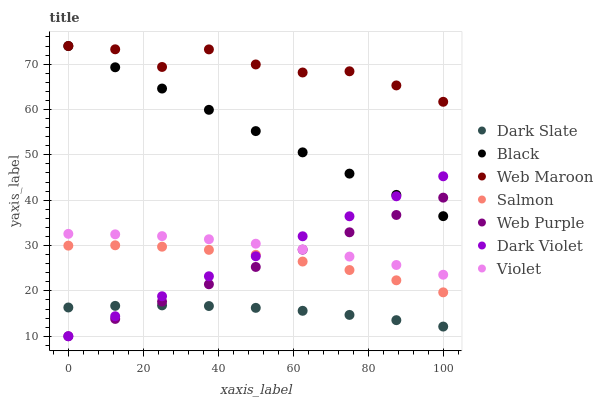Does Dark Slate have the minimum area under the curve?
Answer yes or no. Yes. Does Web Maroon have the maximum area under the curve?
Answer yes or no. Yes. Does Dark Violet have the minimum area under the curve?
Answer yes or no. No. Does Dark Violet have the maximum area under the curve?
Answer yes or no. No. Is Black the smoothest?
Answer yes or no. Yes. Is Web Maroon the roughest?
Answer yes or no. Yes. Is Dark Violet the smoothest?
Answer yes or no. No. Is Dark Violet the roughest?
Answer yes or no. No. Does Dark Violet have the lowest value?
Answer yes or no. Yes. Does Web Maroon have the lowest value?
Answer yes or no. No. Does Black have the highest value?
Answer yes or no. Yes. Does Dark Violet have the highest value?
Answer yes or no. No. Is Dark Slate less than Violet?
Answer yes or no. Yes. Is Salmon greater than Dark Slate?
Answer yes or no. Yes. Does Black intersect Web Purple?
Answer yes or no. Yes. Is Black less than Web Purple?
Answer yes or no. No. Is Black greater than Web Purple?
Answer yes or no. No. Does Dark Slate intersect Violet?
Answer yes or no. No. 